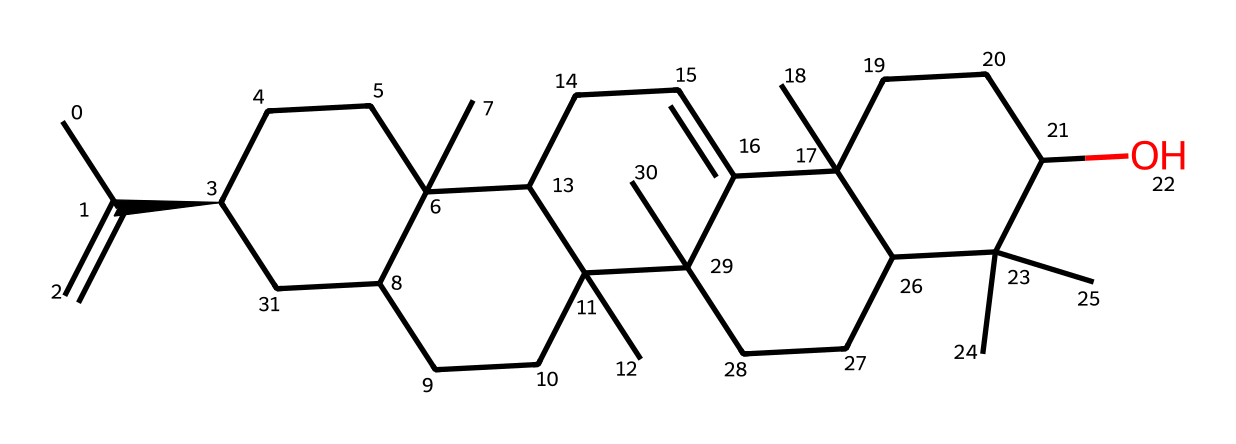What is the main aromatic component found in the chemical structure? The chemical structure is indicative of constituents commonly associated with frankincense, largely comprising sesquiterpenes, particularly boswellic acids. Thus, the main aromatic component is derived from boswellic acid derivatives present in the structure.
Answer: boswellic acids How many carbon atoms are present in this compound? Analyzing the SMILES representation reveals a total of 30 carbon atoms through the count of the 'C' symbols in the structure.
Answer: 30 What type of functional groups can be identified in this chemical? The structure features hydroxyl groups typical of alcohols (see the '-O' in the context of the carbon chain) and has cyclic structures indicative of terpenes. Thus, the main functional groups identified are hydroxyl and alkene groups.
Answer: hydroxyl and alkene Is this compound polar or nonpolar? Given the presence of multiple carbon atoms and the limited amount of polar functional groups, the chemical exhibits a predominant nonpolar character. Nonpolar features stem from long hydrocarbon chains typical of sesquiterpenes.
Answer: nonpolar What is the significance of this chemical in esoteric practices? Frankincense is valued in various spiritual and esoteric traditions for its properties that are thought to enhance meditation, purify spaces, and connect with higher realms, due to its aromatic qualities and historical usage.
Answer: spiritual enhancement How might this chemical structure affect its solubility in water? The presence of extensive nonpolar hydrocarbon chains in the structure suggests low solubility in water, as nonpolar compounds typically do not dissolve well in polar solvents like water.
Answer: low solubility 